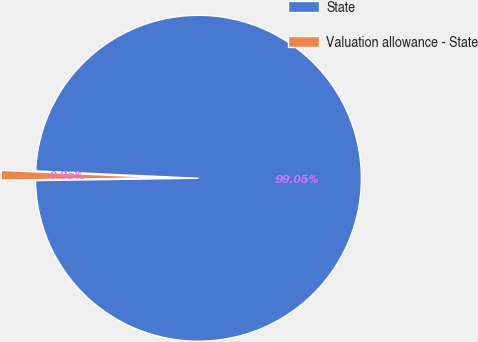<chart> <loc_0><loc_0><loc_500><loc_500><pie_chart><fcel>State<fcel>Valuation allowance - State<nl><fcel>99.05%<fcel>0.95%<nl></chart> 